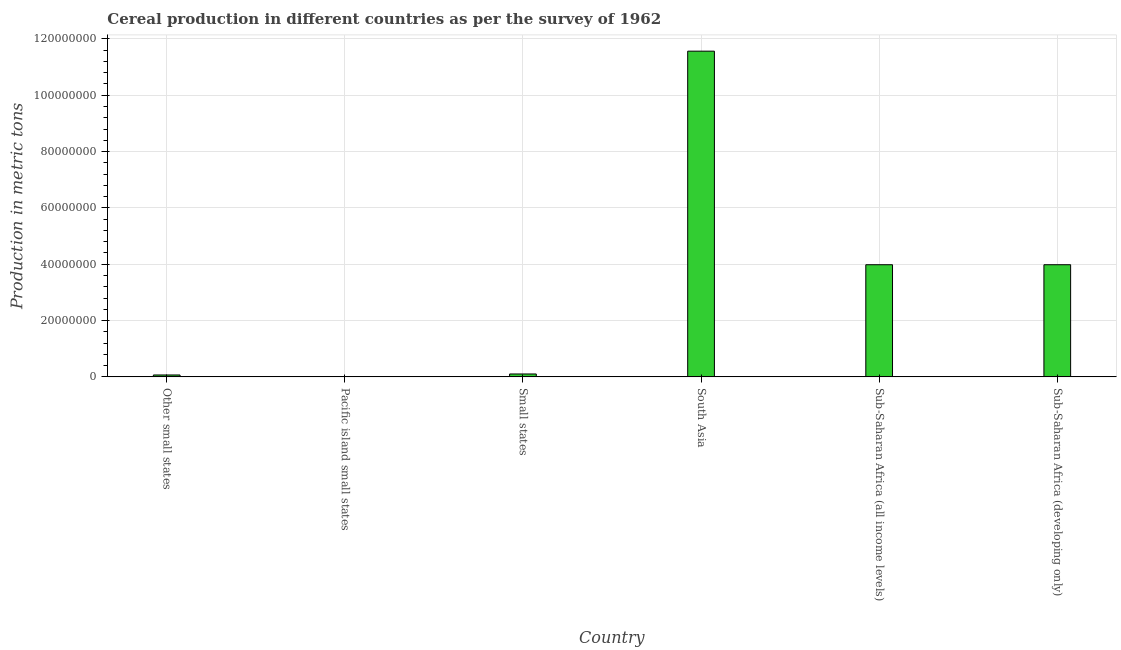What is the title of the graph?
Your answer should be compact. Cereal production in different countries as per the survey of 1962. What is the label or title of the Y-axis?
Provide a succinct answer. Production in metric tons. What is the cereal production in Other small states?
Offer a very short reply. 6.75e+05. Across all countries, what is the maximum cereal production?
Make the answer very short. 1.16e+08. Across all countries, what is the minimum cereal production?
Provide a succinct answer. 2.33e+04. In which country was the cereal production maximum?
Keep it short and to the point. South Asia. In which country was the cereal production minimum?
Keep it short and to the point. Pacific island small states. What is the sum of the cereal production?
Keep it short and to the point. 1.97e+08. What is the difference between the cereal production in Sub-Saharan Africa (all income levels) and Sub-Saharan Africa (developing only)?
Ensure brevity in your answer.  0. What is the average cereal production per country?
Keep it short and to the point. 3.28e+07. What is the median cereal production?
Keep it short and to the point. 2.04e+07. In how many countries, is the cereal production greater than 56000000 metric tons?
Your answer should be very brief. 1. What is the ratio of the cereal production in South Asia to that in Sub-Saharan Africa (all income levels)?
Provide a succinct answer. 2.9. What is the difference between the highest and the second highest cereal production?
Offer a very short reply. 7.58e+07. Is the sum of the cereal production in Small states and Sub-Saharan Africa (developing only) greater than the maximum cereal production across all countries?
Ensure brevity in your answer.  No. What is the difference between the highest and the lowest cereal production?
Give a very brief answer. 1.16e+08. In how many countries, is the cereal production greater than the average cereal production taken over all countries?
Your answer should be compact. 3. How many bars are there?
Offer a terse response. 6. Are all the bars in the graph horizontal?
Provide a short and direct response. No. How many countries are there in the graph?
Give a very brief answer. 6. What is the difference between two consecutive major ticks on the Y-axis?
Your response must be concise. 2.00e+07. What is the Production in metric tons of Other small states?
Offer a very short reply. 6.75e+05. What is the Production in metric tons in Pacific island small states?
Your answer should be very brief. 2.33e+04. What is the Production in metric tons of Small states?
Offer a very short reply. 1.03e+06. What is the Production in metric tons in South Asia?
Your answer should be very brief. 1.16e+08. What is the Production in metric tons of Sub-Saharan Africa (all income levels)?
Give a very brief answer. 3.98e+07. What is the Production in metric tons in Sub-Saharan Africa (developing only)?
Provide a short and direct response. 3.98e+07. What is the difference between the Production in metric tons in Other small states and Pacific island small states?
Provide a succinct answer. 6.52e+05. What is the difference between the Production in metric tons in Other small states and Small states?
Offer a very short reply. -3.53e+05. What is the difference between the Production in metric tons in Other small states and South Asia?
Give a very brief answer. -1.15e+08. What is the difference between the Production in metric tons in Other small states and Sub-Saharan Africa (all income levels)?
Offer a very short reply. -3.91e+07. What is the difference between the Production in metric tons in Other small states and Sub-Saharan Africa (developing only)?
Keep it short and to the point. -3.91e+07. What is the difference between the Production in metric tons in Pacific island small states and Small states?
Your response must be concise. -1.00e+06. What is the difference between the Production in metric tons in Pacific island small states and South Asia?
Offer a very short reply. -1.16e+08. What is the difference between the Production in metric tons in Pacific island small states and Sub-Saharan Africa (all income levels)?
Provide a short and direct response. -3.98e+07. What is the difference between the Production in metric tons in Pacific island small states and Sub-Saharan Africa (developing only)?
Offer a terse response. -3.98e+07. What is the difference between the Production in metric tons in Small states and South Asia?
Offer a terse response. -1.15e+08. What is the difference between the Production in metric tons in Small states and Sub-Saharan Africa (all income levels)?
Give a very brief answer. -3.88e+07. What is the difference between the Production in metric tons in Small states and Sub-Saharan Africa (developing only)?
Ensure brevity in your answer.  -3.88e+07. What is the difference between the Production in metric tons in South Asia and Sub-Saharan Africa (all income levels)?
Keep it short and to the point. 7.58e+07. What is the difference between the Production in metric tons in South Asia and Sub-Saharan Africa (developing only)?
Give a very brief answer. 7.58e+07. What is the ratio of the Production in metric tons in Other small states to that in Pacific island small states?
Provide a short and direct response. 29.02. What is the ratio of the Production in metric tons in Other small states to that in Small states?
Keep it short and to the point. 0.66. What is the ratio of the Production in metric tons in Other small states to that in South Asia?
Your response must be concise. 0.01. What is the ratio of the Production in metric tons in Other small states to that in Sub-Saharan Africa (all income levels)?
Keep it short and to the point. 0.02. What is the ratio of the Production in metric tons in Other small states to that in Sub-Saharan Africa (developing only)?
Your response must be concise. 0.02. What is the ratio of the Production in metric tons in Pacific island small states to that in Small states?
Your response must be concise. 0.02. What is the ratio of the Production in metric tons in Pacific island small states to that in South Asia?
Offer a very short reply. 0. What is the ratio of the Production in metric tons in Small states to that in South Asia?
Make the answer very short. 0.01. What is the ratio of the Production in metric tons in Small states to that in Sub-Saharan Africa (all income levels)?
Your answer should be very brief. 0.03. What is the ratio of the Production in metric tons in Small states to that in Sub-Saharan Africa (developing only)?
Provide a succinct answer. 0.03. What is the ratio of the Production in metric tons in South Asia to that in Sub-Saharan Africa (all income levels)?
Your response must be concise. 2.9. What is the ratio of the Production in metric tons in South Asia to that in Sub-Saharan Africa (developing only)?
Provide a short and direct response. 2.9. 